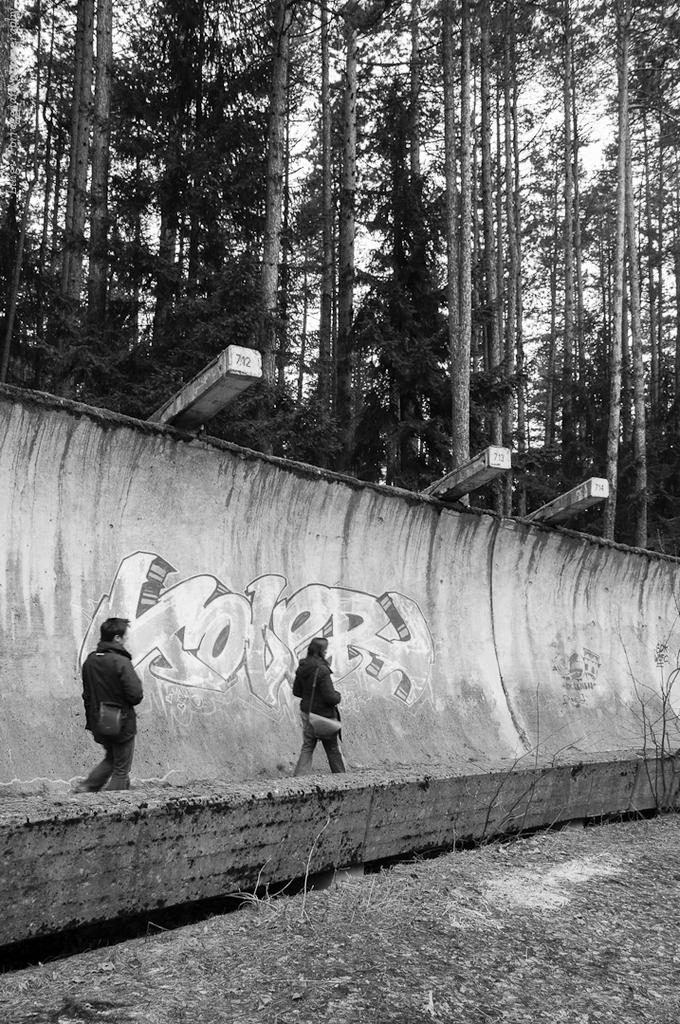What is present in the image that serves as a barrier or divider? There is a wall in the image. What are the two persons in the image doing? The two persons in the image are walking. What type of vegetation can be seen in the image? There are trees visible in the image. How many glass toads are sitting on the wall in the image? There are no glass toads present in the image. What type of ticket can be seen in the hands of the persons walking in the image? There are no tickets visible in the hands of the persons walking in the image. 